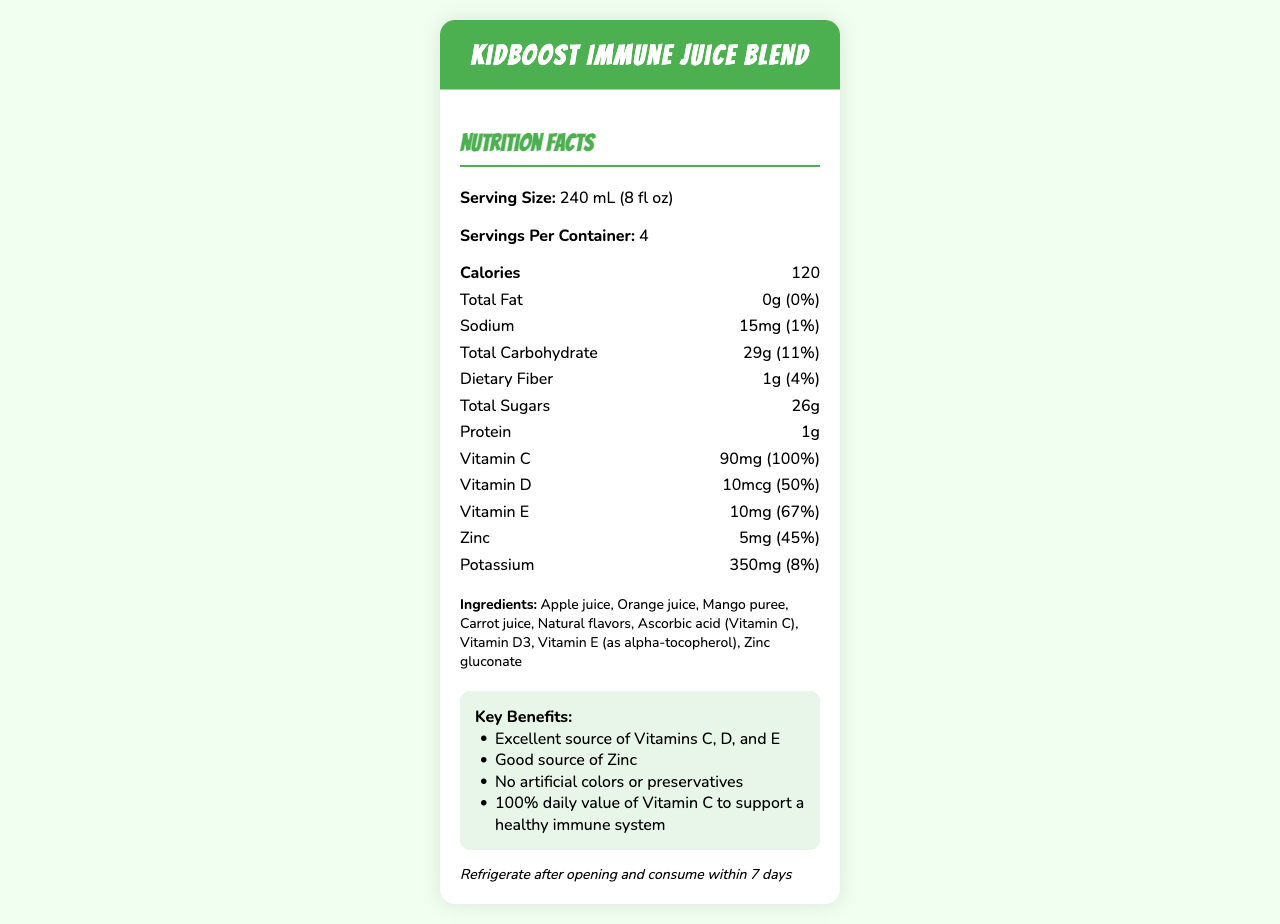how many servings are in one container? The nutrition facts label states that there are 4 servings per container.
Answer: 4 what is the serving size of the KidBoost Immune Juice Blend? The label specifies that the serving size is 240 mL (8 fl oz).
Answer: 240 mL (8 fl oz) how much vitamin C is in one serving? The nutrition facts show that each serving contains 90 mg of vitamin C.
Answer: 90 mg how much potassium does one serving of the juice provide? According to the label, one serving provides 350 mg of potassium.
Answer: 350 mg is there any added sugar in this juice blend? The nutrition facts label shows that there are 0 grams of added sugars.
Answer: No how many calories are in one serving of KidBoost Immune Juice Blend? A. 100 B. 120 C. 150 The label indicates that one serving contains 120 calories.
Answer: B what percentage of daily value does the zinc content in one serving provide? A. 45% B. 50% C. 67% Each serving provides 45% of the daily value for zinc, as stated on the label.
Answer: A is this juice blend a good source of vitamins? The claims on the label state that it is an excellent source of Vitamins C, D, and E, and a good source of Zinc.
Answer: Yes does the product contain any artificial colors or preservatives? The claim statements explicitly mention that there are no artificial colors or preservatives.
Answer: No describe the main benefits and nutritional highlights of KidBoost Immune Juice Blend. The document provides specific details about the nutrient content and ingredient list, emphasizing vitamins and natural ingredients, while the claim statements highlight their benefits.
Answer: The KidBoost Immune Juice Blend is highly nutritious, particularly for children. It contains 90 mg of Vitamin C (100% daily value), 10 mcg of Vitamin D (50% daily value), 10 mg of Vitamin E (67% daily value), and 5 mg of Zinc (45% daily value). The juice has no fat, a low amount of sodium (15 mg), and a moderate amount of carbohydrates (29 g) and sugars (26 g) per serving. It includes an array of natural fruit juices and purees and does not contain artificial colors or preservatives, making it a healthier option. what is the sodium content per serving? As indicated on the label, each serving contains 15 mg of sodium.
Answer: 15 mg are there any allergens in this juice blend? The label states that it is produced in a facility that processes soy and tree nuts, but it does not specify if the juice itself contains any allergens.
Answer: Cannot be determined which company manufactures the KidBoost Immune Juice Blend? The label mentions that PlayFit Nutrition, Inc. manufactures the juice, with their address provided as well.
Answer: PlayFit Nutrition, Inc. what is the total carbohydrate content and its daily value percentage per serving? The label lists 29 grams as the total carbohydrate content per serving, with a daily value percentage of 11%.
Answer: 29 g (11%) how much protein is in one serving of the juice blend? The label clearly shows that one serving contains 1 gram of protein.
Answer: 1 g 